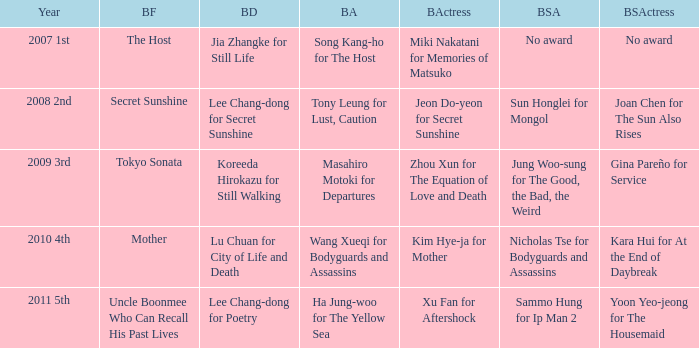Name the best supporting actress for sun honglei for mongol Joan Chen for The Sun Also Rises. 